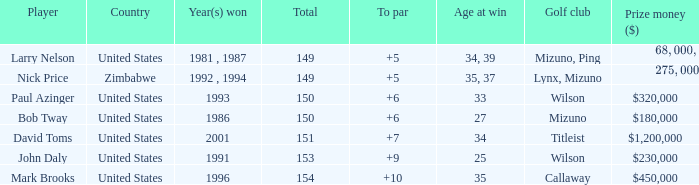What is Zimbabwe's total with a to par higher than 5? None. 